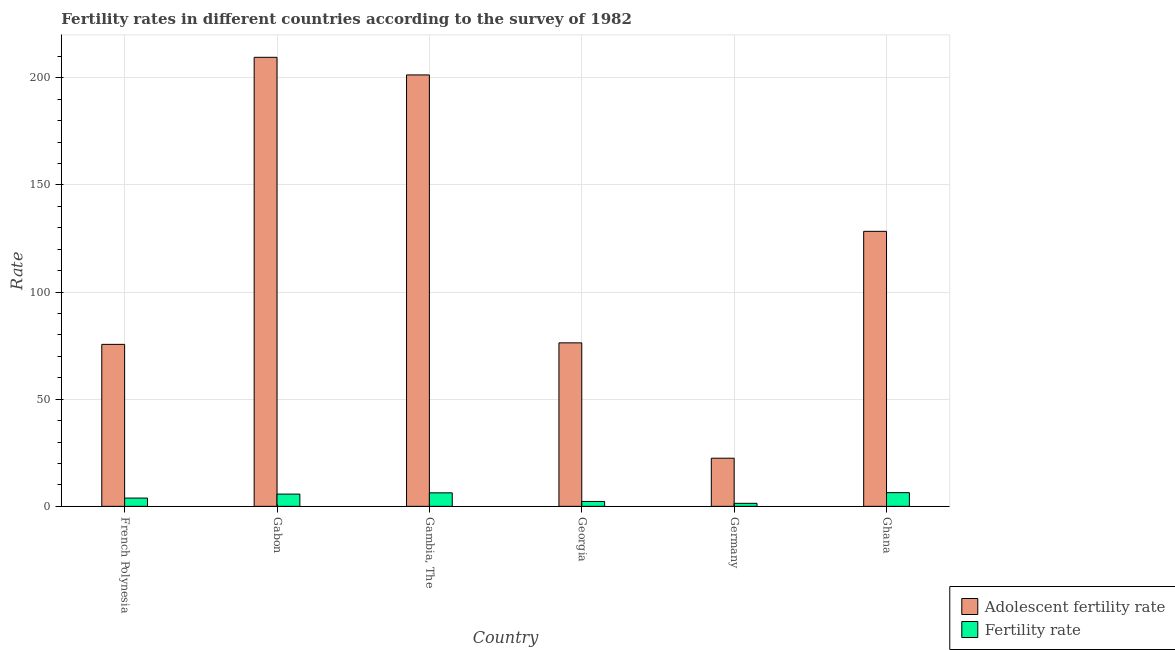How many groups of bars are there?
Make the answer very short. 6. Are the number of bars per tick equal to the number of legend labels?
Provide a succinct answer. Yes. How many bars are there on the 2nd tick from the left?
Your answer should be compact. 2. What is the label of the 1st group of bars from the left?
Provide a succinct answer. French Polynesia. In how many cases, is the number of bars for a given country not equal to the number of legend labels?
Offer a very short reply. 0. What is the fertility rate in Ghana?
Keep it short and to the point. 6.39. Across all countries, what is the maximum adolescent fertility rate?
Ensure brevity in your answer.  209.51. Across all countries, what is the minimum adolescent fertility rate?
Provide a short and direct response. 22.46. In which country was the adolescent fertility rate maximum?
Offer a very short reply. Gabon. In which country was the adolescent fertility rate minimum?
Your response must be concise. Germany. What is the total fertility rate in the graph?
Provide a short and direct response. 25.97. What is the difference between the adolescent fertility rate in French Polynesia and that in Georgia?
Give a very brief answer. -0.7. What is the difference between the adolescent fertility rate in French Polynesia and the fertility rate in Ghana?
Offer a very short reply. 69.19. What is the average adolescent fertility rate per country?
Your answer should be very brief. 118.91. What is the difference between the adolescent fertility rate and fertility rate in Germany?
Ensure brevity in your answer.  21.05. What is the ratio of the fertility rate in Georgia to that in Ghana?
Make the answer very short. 0.36. Is the fertility rate in Gabon less than that in Germany?
Offer a very short reply. No. What is the difference between the highest and the second highest adolescent fertility rate?
Ensure brevity in your answer.  8.21. What is the difference between the highest and the lowest adolescent fertility rate?
Keep it short and to the point. 187.06. What does the 2nd bar from the left in Ghana represents?
Your answer should be very brief. Fertility rate. What does the 2nd bar from the right in French Polynesia represents?
Provide a succinct answer. Adolescent fertility rate. Are all the bars in the graph horizontal?
Offer a very short reply. No. How many countries are there in the graph?
Your answer should be compact. 6. Does the graph contain any zero values?
Make the answer very short. No. Does the graph contain grids?
Offer a terse response. Yes. Where does the legend appear in the graph?
Provide a succinct answer. Bottom right. How many legend labels are there?
Ensure brevity in your answer.  2. How are the legend labels stacked?
Your answer should be very brief. Vertical. What is the title of the graph?
Keep it short and to the point. Fertility rates in different countries according to the survey of 1982. What is the label or title of the Y-axis?
Make the answer very short. Rate. What is the Rate of Adolescent fertility rate in French Polynesia?
Your answer should be very brief. 75.58. What is the Rate in Fertility rate in French Polynesia?
Provide a short and direct response. 3.86. What is the Rate of Adolescent fertility rate in Gabon?
Ensure brevity in your answer.  209.51. What is the Rate in Fertility rate in Gabon?
Offer a very short reply. 5.72. What is the Rate in Adolescent fertility rate in Gambia, The?
Keep it short and to the point. 201.3. What is the Rate of Fertility rate in Gambia, The?
Your answer should be compact. 6.3. What is the Rate in Adolescent fertility rate in Georgia?
Make the answer very short. 76.28. What is the Rate of Fertility rate in Georgia?
Provide a short and direct response. 2.28. What is the Rate in Adolescent fertility rate in Germany?
Provide a short and direct response. 22.46. What is the Rate in Fertility rate in Germany?
Ensure brevity in your answer.  1.41. What is the Rate in Adolescent fertility rate in Ghana?
Keep it short and to the point. 128.32. What is the Rate of Fertility rate in Ghana?
Keep it short and to the point. 6.39. Across all countries, what is the maximum Rate of Adolescent fertility rate?
Your answer should be compact. 209.51. Across all countries, what is the maximum Rate of Fertility rate?
Provide a succinct answer. 6.39. Across all countries, what is the minimum Rate of Adolescent fertility rate?
Make the answer very short. 22.46. Across all countries, what is the minimum Rate of Fertility rate?
Offer a terse response. 1.41. What is the total Rate of Adolescent fertility rate in the graph?
Provide a succinct answer. 713.46. What is the total Rate in Fertility rate in the graph?
Provide a short and direct response. 25.97. What is the difference between the Rate in Adolescent fertility rate in French Polynesia and that in Gabon?
Provide a succinct answer. -133.93. What is the difference between the Rate in Fertility rate in French Polynesia and that in Gabon?
Make the answer very short. -1.86. What is the difference between the Rate of Adolescent fertility rate in French Polynesia and that in Gambia, The?
Your response must be concise. -125.72. What is the difference between the Rate of Fertility rate in French Polynesia and that in Gambia, The?
Your answer should be compact. -2.44. What is the difference between the Rate in Adolescent fertility rate in French Polynesia and that in Georgia?
Give a very brief answer. -0.7. What is the difference between the Rate of Fertility rate in French Polynesia and that in Georgia?
Your answer should be compact. 1.57. What is the difference between the Rate of Adolescent fertility rate in French Polynesia and that in Germany?
Give a very brief answer. 53.12. What is the difference between the Rate in Fertility rate in French Polynesia and that in Germany?
Provide a short and direct response. 2.45. What is the difference between the Rate of Adolescent fertility rate in French Polynesia and that in Ghana?
Your response must be concise. -52.74. What is the difference between the Rate in Fertility rate in French Polynesia and that in Ghana?
Give a very brief answer. -2.53. What is the difference between the Rate of Adolescent fertility rate in Gabon and that in Gambia, The?
Give a very brief answer. 8.21. What is the difference between the Rate of Fertility rate in Gabon and that in Gambia, The?
Make the answer very short. -0.58. What is the difference between the Rate of Adolescent fertility rate in Gabon and that in Georgia?
Your answer should be very brief. 133.23. What is the difference between the Rate of Fertility rate in Gabon and that in Georgia?
Ensure brevity in your answer.  3.44. What is the difference between the Rate of Adolescent fertility rate in Gabon and that in Germany?
Offer a terse response. 187.06. What is the difference between the Rate in Fertility rate in Gabon and that in Germany?
Your answer should be very brief. 4.31. What is the difference between the Rate of Adolescent fertility rate in Gabon and that in Ghana?
Ensure brevity in your answer.  81.19. What is the difference between the Rate in Fertility rate in Gabon and that in Ghana?
Offer a terse response. -0.67. What is the difference between the Rate of Adolescent fertility rate in Gambia, The and that in Georgia?
Your answer should be compact. 125.02. What is the difference between the Rate in Fertility rate in Gambia, The and that in Georgia?
Offer a terse response. 4.02. What is the difference between the Rate in Adolescent fertility rate in Gambia, The and that in Germany?
Offer a very short reply. 178.84. What is the difference between the Rate in Fertility rate in Gambia, The and that in Germany?
Offer a terse response. 4.89. What is the difference between the Rate in Adolescent fertility rate in Gambia, The and that in Ghana?
Make the answer very short. 72.98. What is the difference between the Rate in Fertility rate in Gambia, The and that in Ghana?
Your answer should be very brief. -0.09. What is the difference between the Rate of Adolescent fertility rate in Georgia and that in Germany?
Your answer should be compact. 53.83. What is the difference between the Rate of Fertility rate in Georgia and that in Germany?
Your answer should be very brief. 0.87. What is the difference between the Rate of Adolescent fertility rate in Georgia and that in Ghana?
Your answer should be very brief. -52.04. What is the difference between the Rate in Fertility rate in Georgia and that in Ghana?
Give a very brief answer. -4.11. What is the difference between the Rate of Adolescent fertility rate in Germany and that in Ghana?
Your answer should be compact. -105.86. What is the difference between the Rate of Fertility rate in Germany and that in Ghana?
Your answer should be compact. -4.98. What is the difference between the Rate of Adolescent fertility rate in French Polynesia and the Rate of Fertility rate in Gabon?
Keep it short and to the point. 69.86. What is the difference between the Rate in Adolescent fertility rate in French Polynesia and the Rate in Fertility rate in Gambia, The?
Ensure brevity in your answer.  69.28. What is the difference between the Rate in Adolescent fertility rate in French Polynesia and the Rate in Fertility rate in Georgia?
Your answer should be compact. 73.3. What is the difference between the Rate in Adolescent fertility rate in French Polynesia and the Rate in Fertility rate in Germany?
Offer a terse response. 74.17. What is the difference between the Rate in Adolescent fertility rate in French Polynesia and the Rate in Fertility rate in Ghana?
Your response must be concise. 69.19. What is the difference between the Rate in Adolescent fertility rate in Gabon and the Rate in Fertility rate in Gambia, The?
Make the answer very short. 203.21. What is the difference between the Rate in Adolescent fertility rate in Gabon and the Rate in Fertility rate in Georgia?
Keep it short and to the point. 207.23. What is the difference between the Rate of Adolescent fertility rate in Gabon and the Rate of Fertility rate in Germany?
Offer a very short reply. 208.1. What is the difference between the Rate in Adolescent fertility rate in Gabon and the Rate in Fertility rate in Ghana?
Your answer should be very brief. 203.12. What is the difference between the Rate of Adolescent fertility rate in Gambia, The and the Rate of Fertility rate in Georgia?
Ensure brevity in your answer.  199.02. What is the difference between the Rate of Adolescent fertility rate in Gambia, The and the Rate of Fertility rate in Germany?
Offer a very short reply. 199.89. What is the difference between the Rate of Adolescent fertility rate in Gambia, The and the Rate of Fertility rate in Ghana?
Offer a terse response. 194.91. What is the difference between the Rate in Adolescent fertility rate in Georgia and the Rate in Fertility rate in Germany?
Keep it short and to the point. 74.87. What is the difference between the Rate of Adolescent fertility rate in Georgia and the Rate of Fertility rate in Ghana?
Offer a terse response. 69.89. What is the difference between the Rate of Adolescent fertility rate in Germany and the Rate of Fertility rate in Ghana?
Offer a terse response. 16.07. What is the average Rate of Adolescent fertility rate per country?
Provide a short and direct response. 118.91. What is the average Rate of Fertility rate per country?
Offer a very short reply. 4.33. What is the difference between the Rate in Adolescent fertility rate and Rate in Fertility rate in French Polynesia?
Provide a succinct answer. 71.72. What is the difference between the Rate of Adolescent fertility rate and Rate of Fertility rate in Gabon?
Provide a short and direct response. 203.79. What is the difference between the Rate in Adolescent fertility rate and Rate in Fertility rate in Gambia, The?
Ensure brevity in your answer.  195. What is the difference between the Rate of Adolescent fertility rate and Rate of Fertility rate in Germany?
Your answer should be very brief. 21.05. What is the difference between the Rate in Adolescent fertility rate and Rate in Fertility rate in Ghana?
Ensure brevity in your answer.  121.93. What is the ratio of the Rate in Adolescent fertility rate in French Polynesia to that in Gabon?
Give a very brief answer. 0.36. What is the ratio of the Rate in Fertility rate in French Polynesia to that in Gabon?
Keep it short and to the point. 0.67. What is the ratio of the Rate in Adolescent fertility rate in French Polynesia to that in Gambia, The?
Offer a terse response. 0.38. What is the ratio of the Rate of Fertility rate in French Polynesia to that in Gambia, The?
Offer a very short reply. 0.61. What is the ratio of the Rate of Fertility rate in French Polynesia to that in Georgia?
Your answer should be very brief. 1.69. What is the ratio of the Rate of Adolescent fertility rate in French Polynesia to that in Germany?
Your answer should be very brief. 3.37. What is the ratio of the Rate in Fertility rate in French Polynesia to that in Germany?
Offer a terse response. 2.74. What is the ratio of the Rate in Adolescent fertility rate in French Polynesia to that in Ghana?
Provide a succinct answer. 0.59. What is the ratio of the Rate of Fertility rate in French Polynesia to that in Ghana?
Offer a very short reply. 0.6. What is the ratio of the Rate in Adolescent fertility rate in Gabon to that in Gambia, The?
Provide a short and direct response. 1.04. What is the ratio of the Rate in Fertility rate in Gabon to that in Gambia, The?
Ensure brevity in your answer.  0.91. What is the ratio of the Rate of Adolescent fertility rate in Gabon to that in Georgia?
Your answer should be compact. 2.75. What is the ratio of the Rate in Fertility rate in Gabon to that in Georgia?
Your response must be concise. 2.51. What is the ratio of the Rate of Adolescent fertility rate in Gabon to that in Germany?
Make the answer very short. 9.33. What is the ratio of the Rate of Fertility rate in Gabon to that in Germany?
Provide a short and direct response. 4.06. What is the ratio of the Rate of Adolescent fertility rate in Gabon to that in Ghana?
Provide a short and direct response. 1.63. What is the ratio of the Rate of Fertility rate in Gabon to that in Ghana?
Offer a terse response. 0.9. What is the ratio of the Rate of Adolescent fertility rate in Gambia, The to that in Georgia?
Provide a short and direct response. 2.64. What is the ratio of the Rate in Fertility rate in Gambia, The to that in Georgia?
Your response must be concise. 2.76. What is the ratio of the Rate in Adolescent fertility rate in Gambia, The to that in Germany?
Your answer should be very brief. 8.96. What is the ratio of the Rate in Fertility rate in Gambia, The to that in Germany?
Give a very brief answer. 4.47. What is the ratio of the Rate in Adolescent fertility rate in Gambia, The to that in Ghana?
Your answer should be very brief. 1.57. What is the ratio of the Rate of Fertility rate in Gambia, The to that in Ghana?
Provide a short and direct response. 0.99. What is the ratio of the Rate of Adolescent fertility rate in Georgia to that in Germany?
Offer a terse response. 3.4. What is the ratio of the Rate of Fertility rate in Georgia to that in Germany?
Ensure brevity in your answer.  1.62. What is the ratio of the Rate of Adolescent fertility rate in Georgia to that in Ghana?
Offer a terse response. 0.59. What is the ratio of the Rate of Fertility rate in Georgia to that in Ghana?
Your response must be concise. 0.36. What is the ratio of the Rate in Adolescent fertility rate in Germany to that in Ghana?
Keep it short and to the point. 0.17. What is the ratio of the Rate of Fertility rate in Germany to that in Ghana?
Your answer should be very brief. 0.22. What is the difference between the highest and the second highest Rate in Adolescent fertility rate?
Make the answer very short. 8.21. What is the difference between the highest and the second highest Rate in Fertility rate?
Your answer should be very brief. 0.09. What is the difference between the highest and the lowest Rate in Adolescent fertility rate?
Provide a short and direct response. 187.06. What is the difference between the highest and the lowest Rate of Fertility rate?
Offer a very short reply. 4.98. 